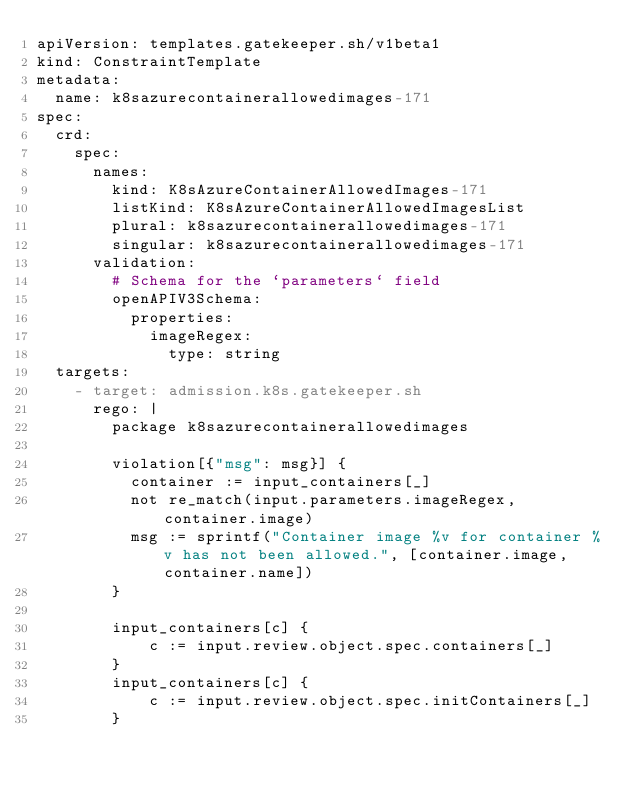Convert code to text. <code><loc_0><loc_0><loc_500><loc_500><_YAML_>apiVersion: templates.gatekeeper.sh/v1beta1
kind: ConstraintTemplate
metadata:
  name: k8sazurecontainerallowedimages-171
spec:
  crd:
    spec:
      names:
        kind: K8sAzureContainerAllowedImages-171
        listKind: K8sAzureContainerAllowedImagesList
        plural: k8sazurecontainerallowedimages-171
        singular: k8sazurecontainerallowedimages-171
      validation:
        # Schema for the `parameters` field
        openAPIV3Schema:
          properties:
            imageRegex:
              type: string
  targets:
    - target: admission.k8s.gatekeeper.sh
      rego: |
        package k8sazurecontainerallowedimages

        violation[{"msg": msg}] {
          container := input_containers[_]
          not re_match(input.parameters.imageRegex, container.image)
          msg := sprintf("Container image %v for container %v has not been allowed.", [container.image, container.name])
        }

        input_containers[c] {
            c := input.review.object.spec.containers[_]
        }
        input_containers[c] {
            c := input.review.object.spec.initContainers[_]
        }</code> 